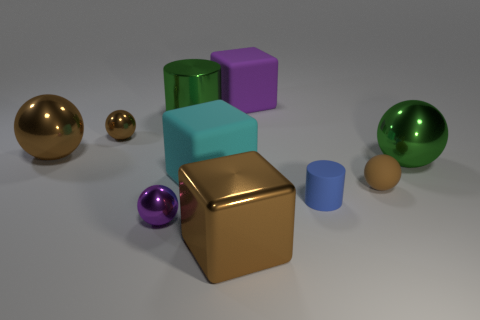How many tiny things are left of the tiny rubber sphere? To the left of the tiny rubber sphere, there appears to be one small golden sphere and two little cubes. While the definition of 'tiny' can be subjective, if we consider objects significantly smaller than the central gold cube to be 'tiny', then there are three tiny objects to the left of the tiny rubber sphere. 